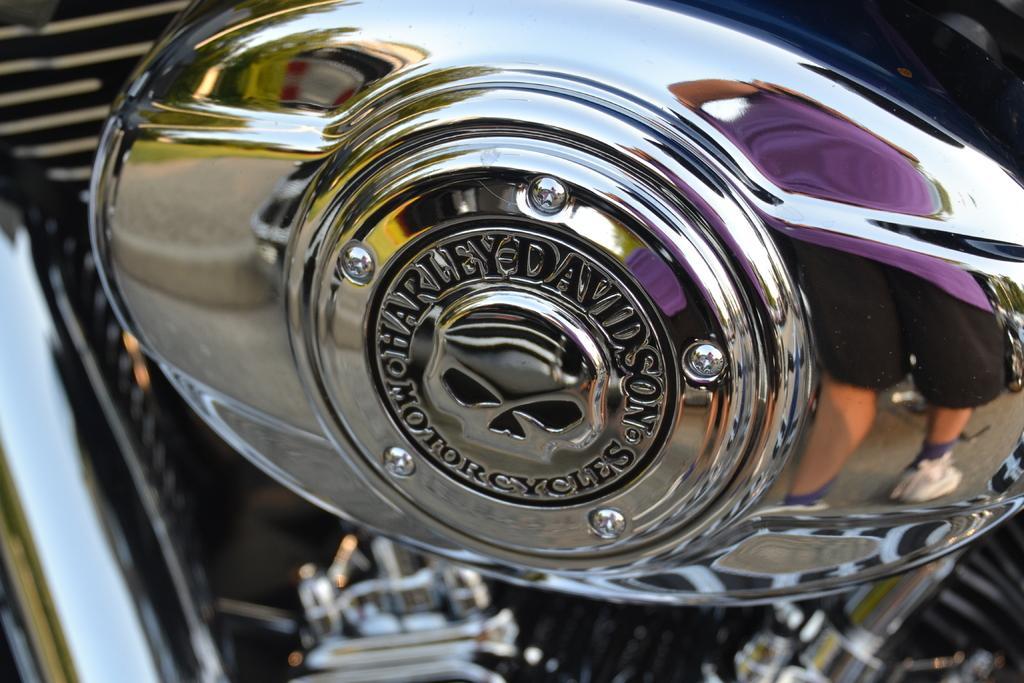Please provide a concise description of this image. In this image we can see that there is a metal tank of a motorbike. 